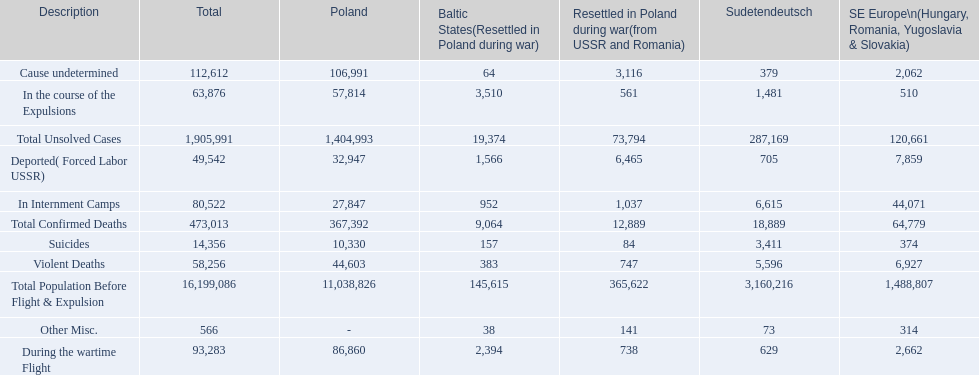How many total confirmed deaths were there in the baltic states? 9,064. How many deaths had an undetermined cause? 64. How many deaths in that region were miscellaneous? 38. Were there more deaths from an undetermined cause or that were listed as miscellaneous? Cause undetermined. 